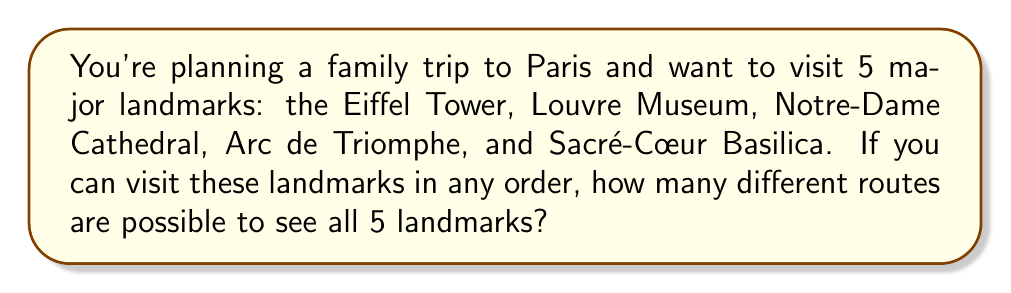Give your solution to this math problem. Let's approach this step-by-step:

1) This problem is a perfect application of permutations. We need to arrange 5 distinct landmarks in different orders.

2) The formula for permutations of n distinct objects is:

   $$P(n) = n!$$

   Where $n!$ (n factorial) is the product of all positive integers less than or equal to n.

3) In this case, $n = 5$ (5 landmarks).

4) Let's calculate $5!$:

   $$5! = 5 \times 4 \times 3 \times 2 \times 1 = 120$$

5) Therefore, there are 120 different possible routes to visit all 5 landmarks.

This means you and your children have many options to plan your day in Paris, allowing for flexibility based on your energy levels and interests!
Answer: $120$ 